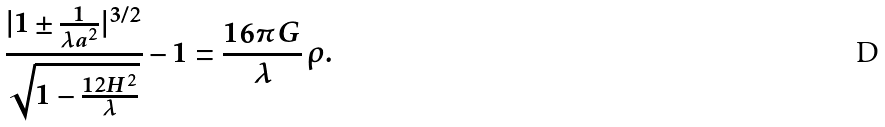<formula> <loc_0><loc_0><loc_500><loc_500>\frac { | 1 \pm \frac { 1 } { \lambda a ^ { 2 } } | ^ { 3 / 2 } } { \sqrt { 1 - \frac { 1 2 H ^ { 2 } } { \lambda } } } - 1 = \frac { 1 6 \pi G } { \lambda } \, \rho .</formula> 